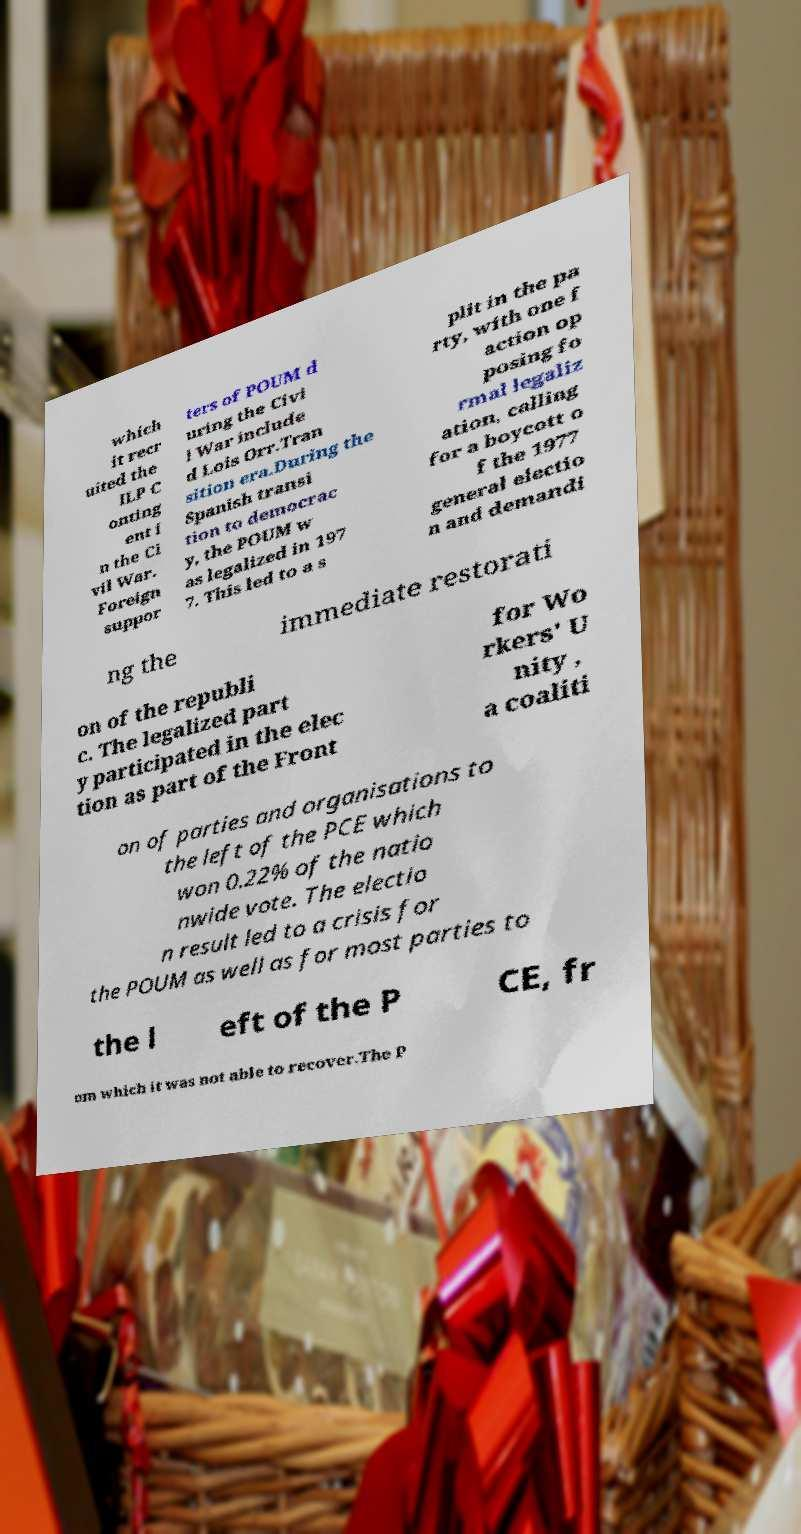Please identify and transcribe the text found in this image. which it recr uited the ILP C onting ent i n the Ci vil War. Foreign suppor ters of POUM d uring the Civi l War include d Lois Orr.Tran sition era.During the Spanish transi tion to democrac y, the POUM w as legalized in 197 7. This led to a s plit in the pa rty, with one f action op posing fo rmal legaliz ation, calling for a boycott o f the 1977 general electio n and demandi ng the immediate restorati on of the republi c. The legalized part y participated in the elec tion as part of the Front for Wo rkers' U nity , a coaliti on of parties and organisations to the left of the PCE which won 0.22% of the natio nwide vote. The electio n result led to a crisis for the POUM as well as for most parties to the l eft of the P CE, fr om which it was not able to recover.The P 